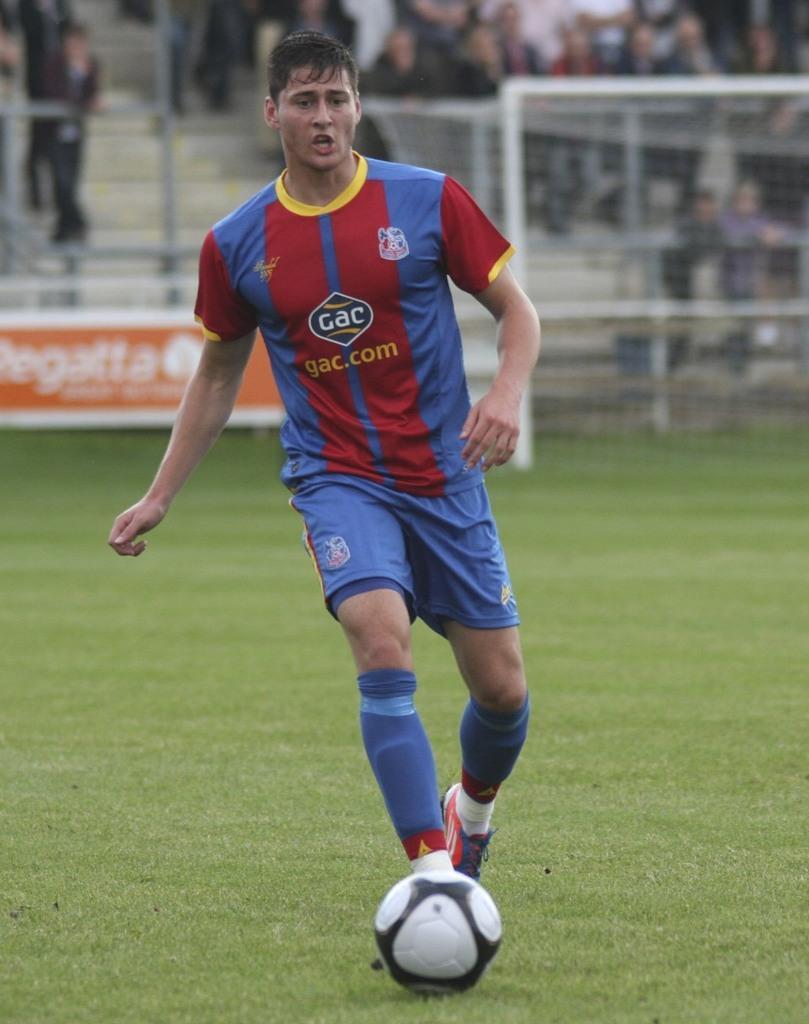In one or two sentences, can you explain what this image depicts? Here is a football player, he is wearing blue color dress,blue color socks and he is playing with a ball. There is a green color ground, behind this person there are spectators who are watching the game. 